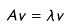<formula> <loc_0><loc_0><loc_500><loc_500>A v = \lambda v</formula> 